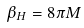Convert formula to latex. <formula><loc_0><loc_0><loc_500><loc_500>\beta _ { H } = 8 \pi M</formula> 